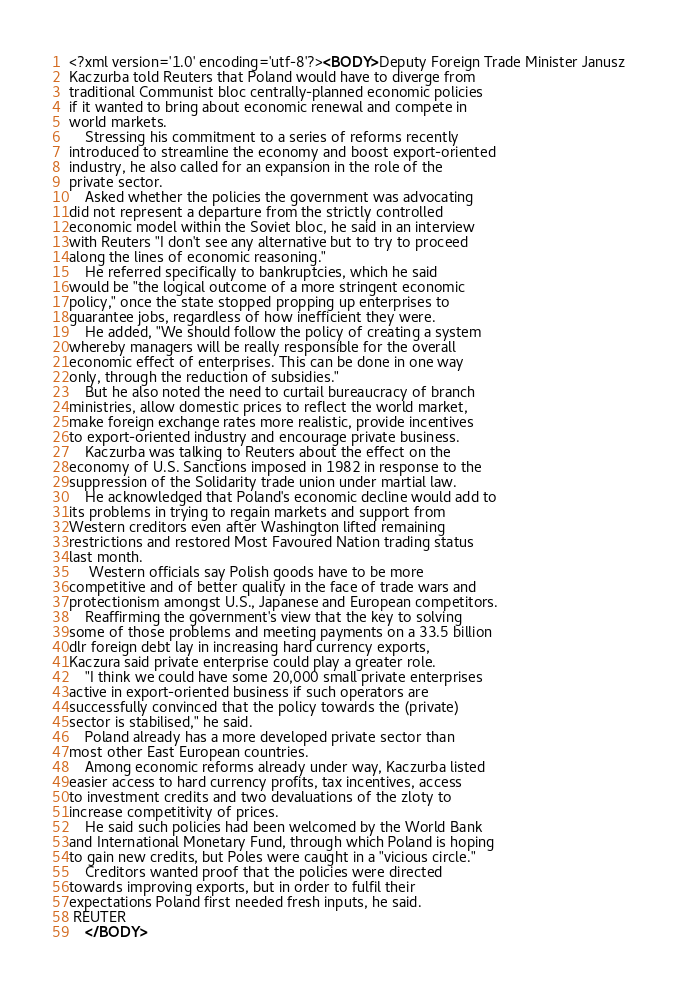<code> <loc_0><loc_0><loc_500><loc_500><_XML_><?xml version='1.0' encoding='utf-8'?><BODY>Deputy Foreign Trade Minister Janusz
Kaczurba told Reuters that Poland would have to diverge from
traditional Communist bloc centrally-planned economic policies
if it wanted to bring about economic renewal and compete in
world markets.
    Stressing his commitment to a series of reforms recently
introduced to streamline the economy and boost export-oriented
industry, he also called for an expansion in the role of the
private sector.
    Asked whether the policies the government was advocating
did not represent a departure from the strictly controlled
economic model within the Soviet bloc, he said in an interview
with Reuters "I don't see any alternative but to try to proceed
along the lines of economic reasoning."
    He referred specifically to bankruptcies, which he said
would be "the logical outcome of a more stringent economic
policy," once the state stopped propping up enterprises to
guarantee jobs, regardless of how inefficient they were.
    He added, "We should follow the policy of creating a system
whereby managers will be really responsible for the overall
economic effect of enterprises. This can be done in one way
only, through the reduction of subsidies."
    But he also noted the need to curtail bureaucracy of branch
ministries, allow domestic prices to reflect the world market,
make foreign exchange rates more realistic, provide incentives
to export-oriented industry and encourage private business.
    Kaczurba was talking to Reuters about the effect on the
economy of U.S. Sanctions imposed in 1982 in response to the
suppression of the Solidarity trade union under martial law.
    He acknowledged that Poland's economic decline would add to
its problems in trying to regain markets and support from
Western creditors even after Washington lifted remaining
restrictions and restored Most Favoured Nation trading status
last month.
     Western officials say Polish goods have to be more
competitive and of better quality in the face of trade wars and
protectionism amongst U.S., Japanese and European competitors.
    Reaffirming the government's view that the key to solving
some of those problems and meeting payments on a 33.5 billion
dlr foreign debt lay in increasing hard currency exports,
Kaczura said private enterprise could play a greater role.
    "I think we could have some 20,000 small private enterprises
active in export-oriented business if such operators are
successfully convinced that the policy towards the (private)
sector is stabilised," he said.
    Poland already has a more developed private sector than
most other East European countries.
    Among economic reforms already under way, Kaczurba listed
easier access to hard currency profits, tax incentives, access
to investment credits and two devaluations of the zloty to
increase competitivity of prices.
    He said such policies had been welcomed by the World Bank
and International Monetary Fund, through which Poland is hoping
to gain new credits, but Poles were caught in a "vicious circle."
    Creditors wanted proof that the policies were directed
towards improving exports, but in order to fulfil their
expectations Poland first needed fresh inputs, he said.
 REUTER
    </BODY></code> 